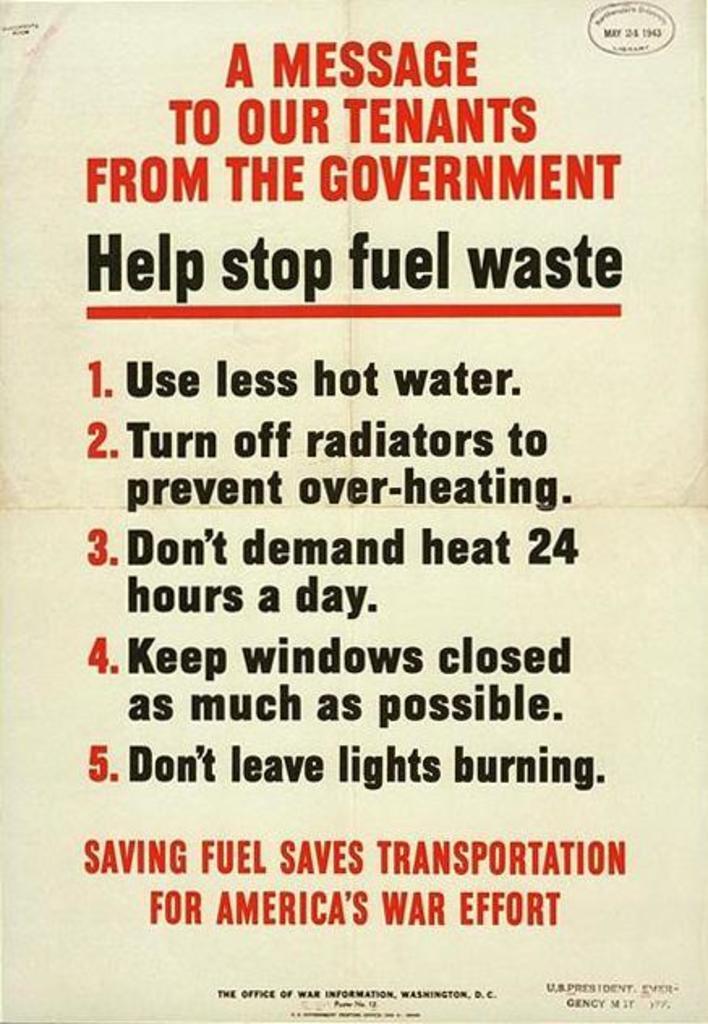How many tips are listed on the paper?
Your response must be concise. 5. What is tip 1?
Your response must be concise. Use less hot water. 